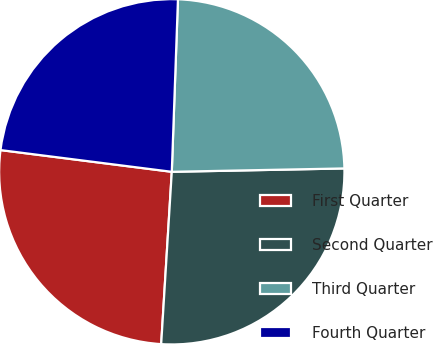Convert chart. <chart><loc_0><loc_0><loc_500><loc_500><pie_chart><fcel>First Quarter<fcel>Second Quarter<fcel>Third Quarter<fcel>Fourth Quarter<nl><fcel>26.03%<fcel>26.29%<fcel>24.12%<fcel>23.56%<nl></chart> 